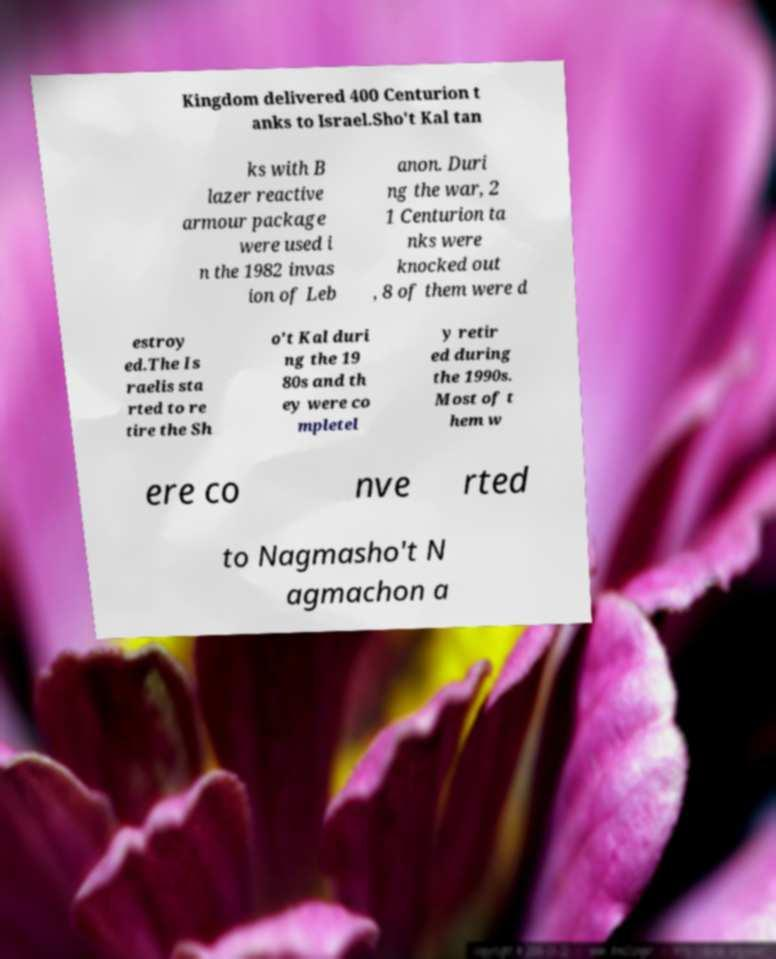Please read and relay the text visible in this image. What does it say? Kingdom delivered 400 Centurion t anks to Israel.Sho't Kal tan ks with B lazer reactive armour package were used i n the 1982 invas ion of Leb anon. Duri ng the war, 2 1 Centurion ta nks were knocked out , 8 of them were d estroy ed.The Is raelis sta rted to re tire the Sh o't Kal duri ng the 19 80s and th ey were co mpletel y retir ed during the 1990s. Most of t hem w ere co nve rted to Nagmasho't N agmachon a 